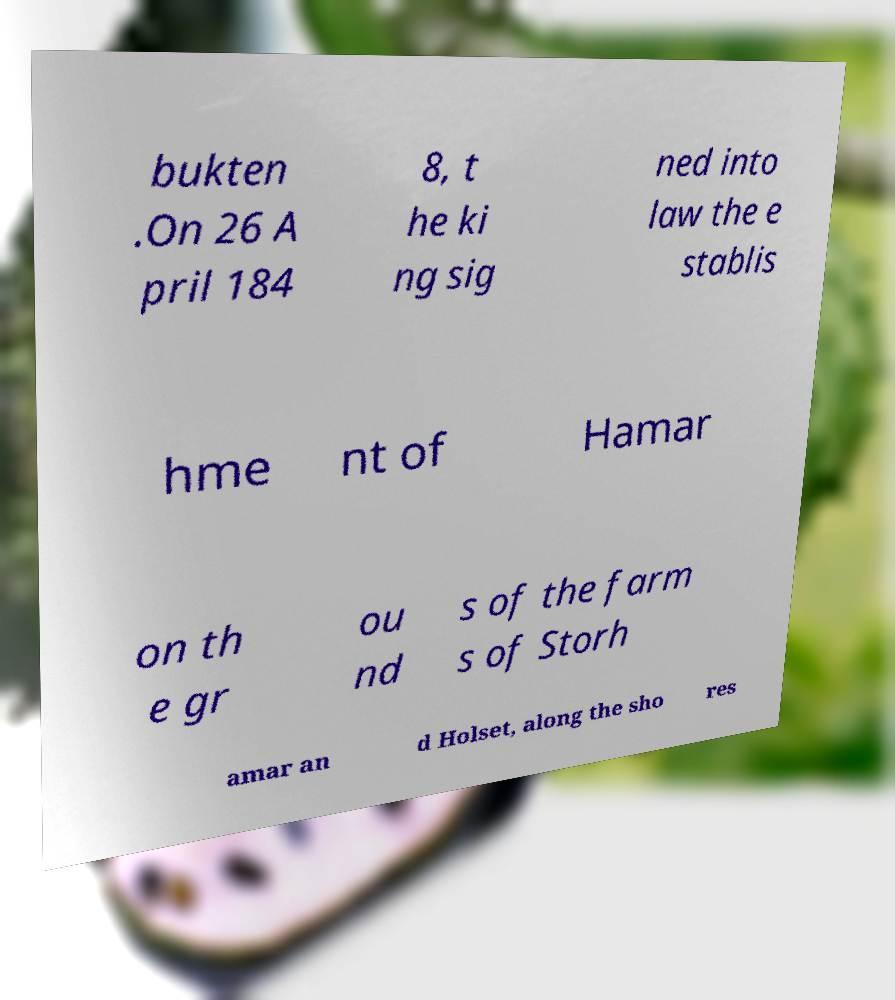Can you read and provide the text displayed in the image?This photo seems to have some interesting text. Can you extract and type it out for me? bukten .On 26 A pril 184 8, t he ki ng sig ned into law the e stablis hme nt of Hamar on th e gr ou nd s of the farm s of Storh amar an d Holset, along the sho res 